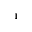<formula> <loc_0><loc_0><loc_500><loc_500>_ { 1 }</formula> 